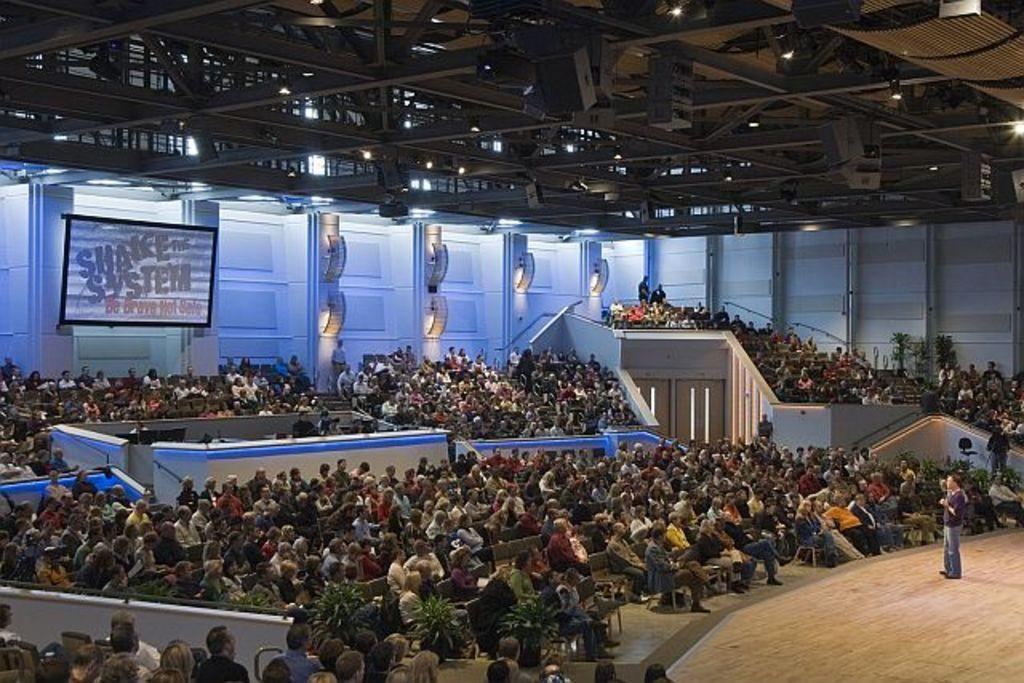What is happening on the stage in the image? There is a person standing on the stage in the image. Who else is present in the image besides the person on the stage? There are people sitting in the audience in the image. Are there any decorative elements visible in the image? Yes, there are flower pots present in the image. What type of wheel can be seen in the image? There is no wheel present in the image. How many houses are visible in the image? There are no houses visible in the image. 